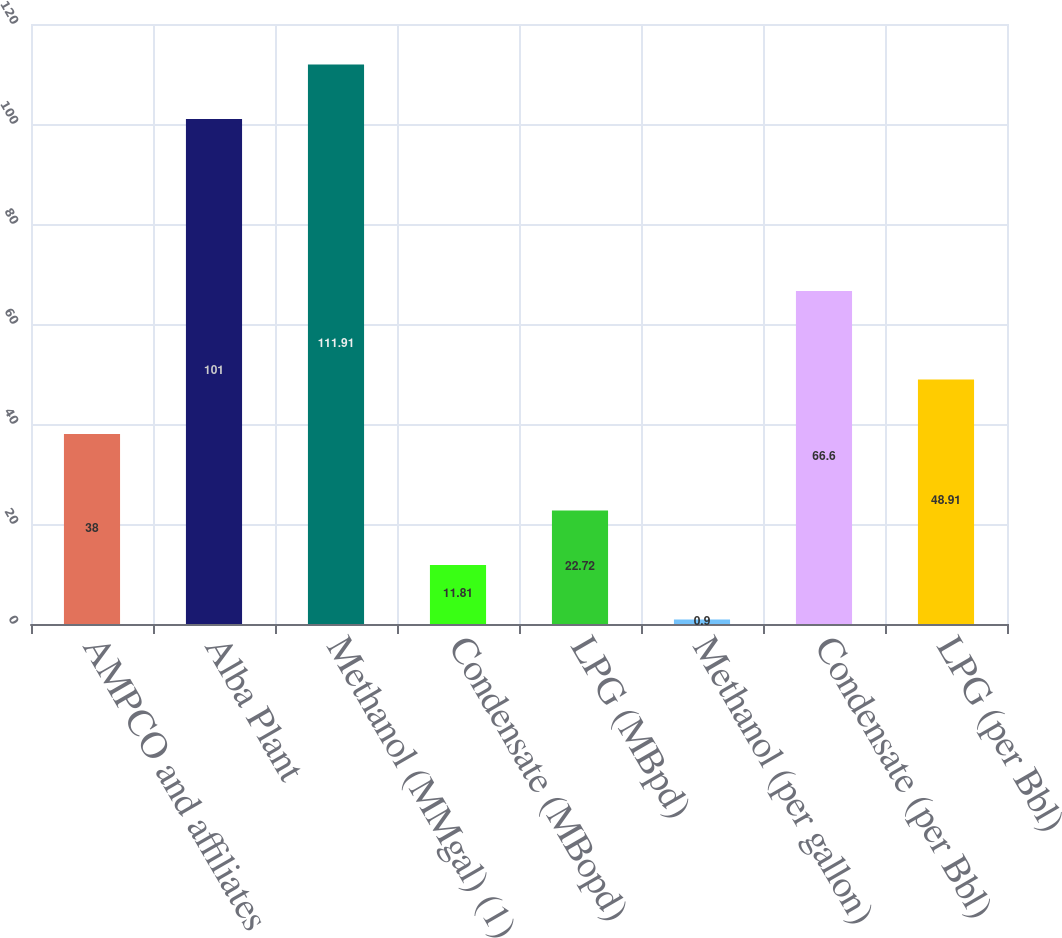Convert chart. <chart><loc_0><loc_0><loc_500><loc_500><bar_chart><fcel>AMPCO and affiliates<fcel>Alba Plant<fcel>Methanol (MMgal) (1)<fcel>Condensate (MBopd)<fcel>LPG (MBpd)<fcel>Methanol (per gallon)<fcel>Condensate (per Bbl)<fcel>LPG (per Bbl)<nl><fcel>38<fcel>101<fcel>111.91<fcel>11.81<fcel>22.72<fcel>0.9<fcel>66.6<fcel>48.91<nl></chart> 